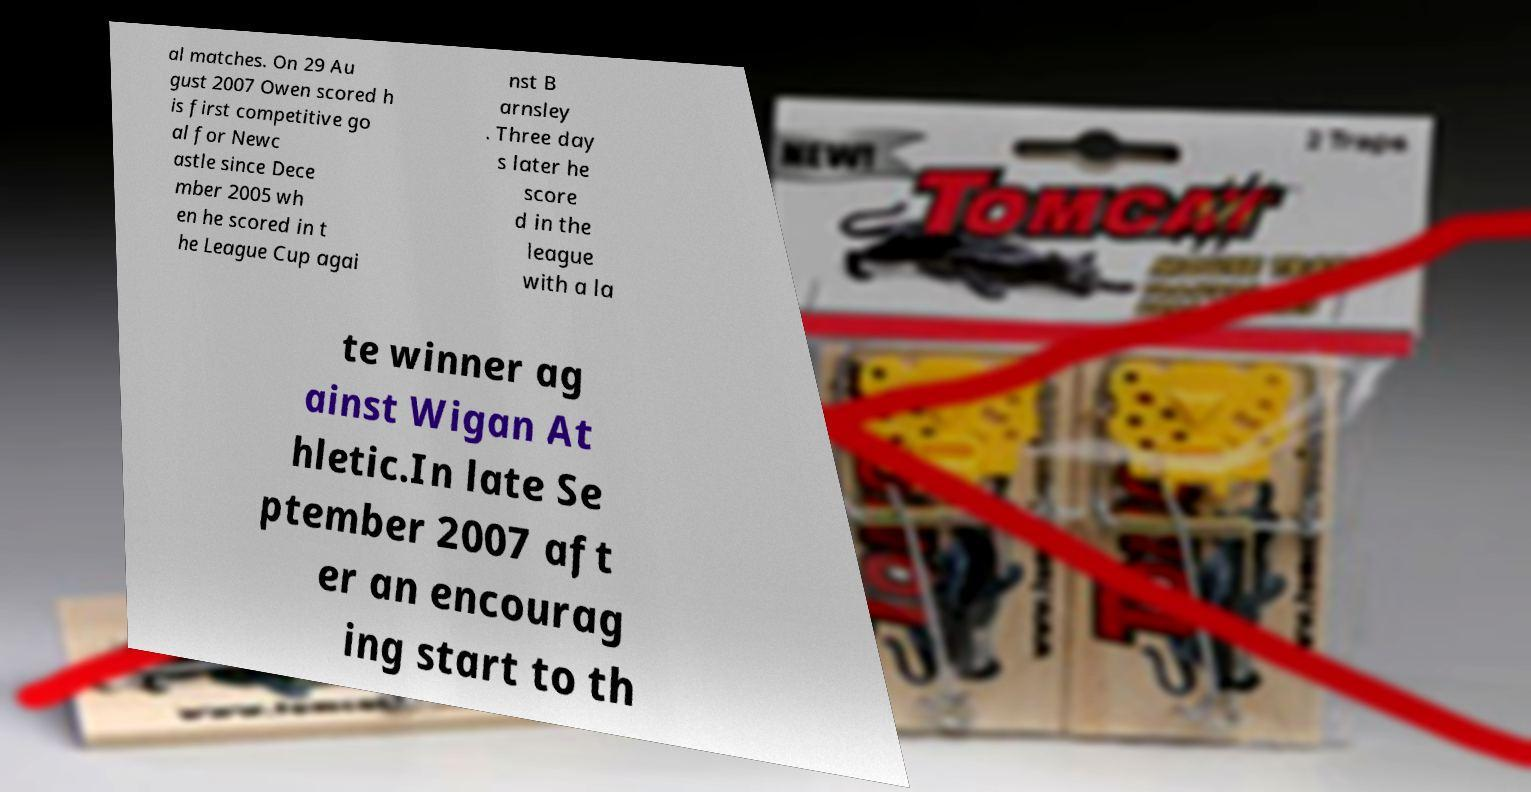There's text embedded in this image that I need extracted. Can you transcribe it verbatim? al matches. On 29 Au gust 2007 Owen scored h is first competitive go al for Newc astle since Dece mber 2005 wh en he scored in t he League Cup agai nst B arnsley . Three day s later he score d in the league with a la te winner ag ainst Wigan At hletic.In late Se ptember 2007 aft er an encourag ing start to th 